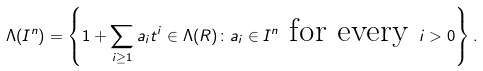Convert formula to latex. <formula><loc_0><loc_0><loc_500><loc_500>\Lambda ( I ^ { n } ) = \left \{ 1 + \sum _ { i \geq 1 } a _ { i } t ^ { i } \in \Lambda ( R ) \colon a _ { i } \in I ^ { n } \text { for every } i > 0 \right \} .</formula> 